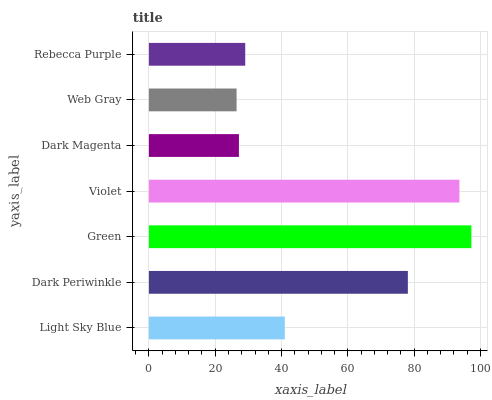Is Web Gray the minimum?
Answer yes or no. Yes. Is Green the maximum?
Answer yes or no. Yes. Is Dark Periwinkle the minimum?
Answer yes or no. No. Is Dark Periwinkle the maximum?
Answer yes or no. No. Is Dark Periwinkle greater than Light Sky Blue?
Answer yes or no. Yes. Is Light Sky Blue less than Dark Periwinkle?
Answer yes or no. Yes. Is Light Sky Blue greater than Dark Periwinkle?
Answer yes or no. No. Is Dark Periwinkle less than Light Sky Blue?
Answer yes or no. No. Is Light Sky Blue the high median?
Answer yes or no. Yes. Is Light Sky Blue the low median?
Answer yes or no. Yes. Is Dark Magenta the high median?
Answer yes or no. No. Is Web Gray the low median?
Answer yes or no. No. 